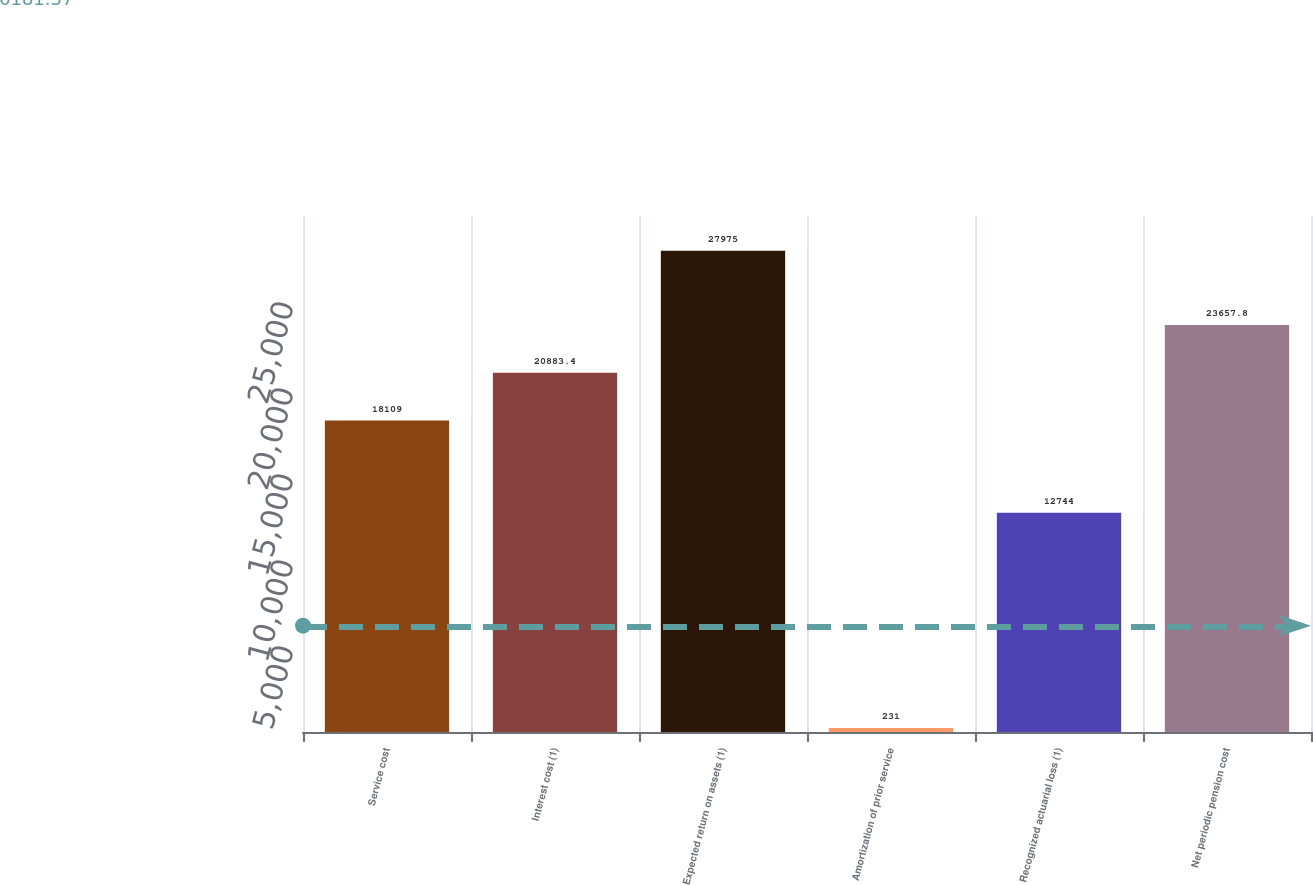Convert chart. <chart><loc_0><loc_0><loc_500><loc_500><bar_chart><fcel>Service cost<fcel>Interest cost (1)<fcel>Expected return on assets (1)<fcel>Amortization of prior service<fcel>Recognized actuarial loss (1)<fcel>Net periodic pension cost<nl><fcel>18109<fcel>20883.4<fcel>27975<fcel>231<fcel>12744<fcel>23657.8<nl></chart> 